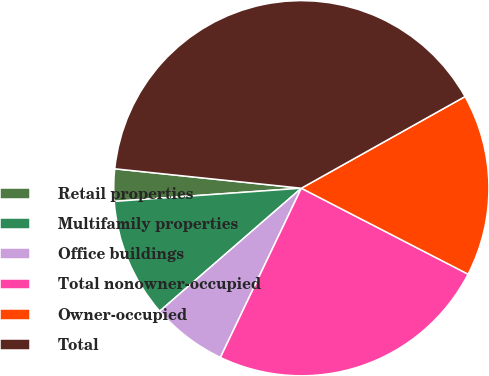Convert chart to OTSL. <chart><loc_0><loc_0><loc_500><loc_500><pie_chart><fcel>Retail properties<fcel>Multifamily properties<fcel>Office buildings<fcel>Total nonowner-occupied<fcel>Owner-occupied<fcel>Total<nl><fcel>2.77%<fcel>10.26%<fcel>6.52%<fcel>24.52%<fcel>15.7%<fcel>40.22%<nl></chart> 